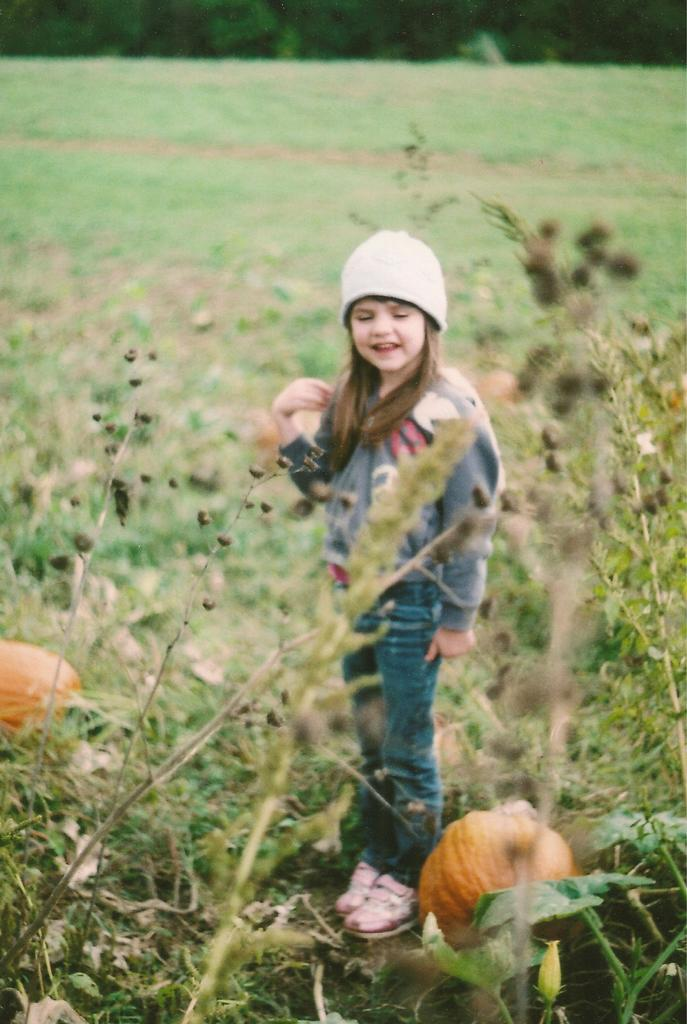Who is in the image? There is a girl in the image. What is the girl doing in the image? The girl is standing and smiling. What is the girl wearing on her head? The girl is wearing a cap. What objects can be seen in the image besides the girl? There are pumpkins and plants in the image. How would you describe the background of the image? The background has a blurred view. What type of ground surface is visible in the image? There is grass visible in the image. Can you hear the girl whistling in the image? There is no indication of sound in the image, so it cannot be determined if the girl is whistling or not. 